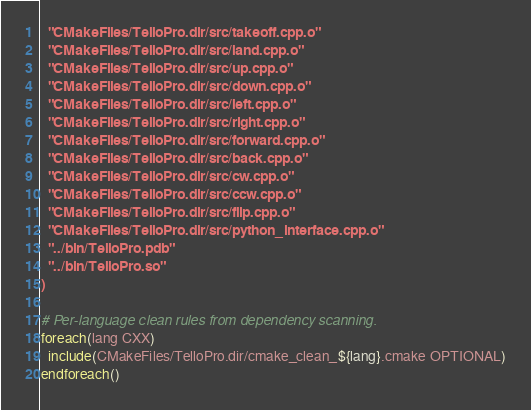Convert code to text. <code><loc_0><loc_0><loc_500><loc_500><_CMake_>  "CMakeFiles/TelloPro.dir/src/takeoff.cpp.o"
  "CMakeFiles/TelloPro.dir/src/land.cpp.o"
  "CMakeFiles/TelloPro.dir/src/up.cpp.o"
  "CMakeFiles/TelloPro.dir/src/down.cpp.o"
  "CMakeFiles/TelloPro.dir/src/left.cpp.o"
  "CMakeFiles/TelloPro.dir/src/right.cpp.o"
  "CMakeFiles/TelloPro.dir/src/forward.cpp.o"
  "CMakeFiles/TelloPro.dir/src/back.cpp.o"
  "CMakeFiles/TelloPro.dir/src/cw.cpp.o"
  "CMakeFiles/TelloPro.dir/src/ccw.cpp.o"
  "CMakeFiles/TelloPro.dir/src/flip.cpp.o"
  "CMakeFiles/TelloPro.dir/src/python_interface.cpp.o"
  "../bin/TelloPro.pdb"
  "../bin/TelloPro.so"
)

# Per-language clean rules from dependency scanning.
foreach(lang CXX)
  include(CMakeFiles/TelloPro.dir/cmake_clean_${lang}.cmake OPTIONAL)
endforeach()
</code> 